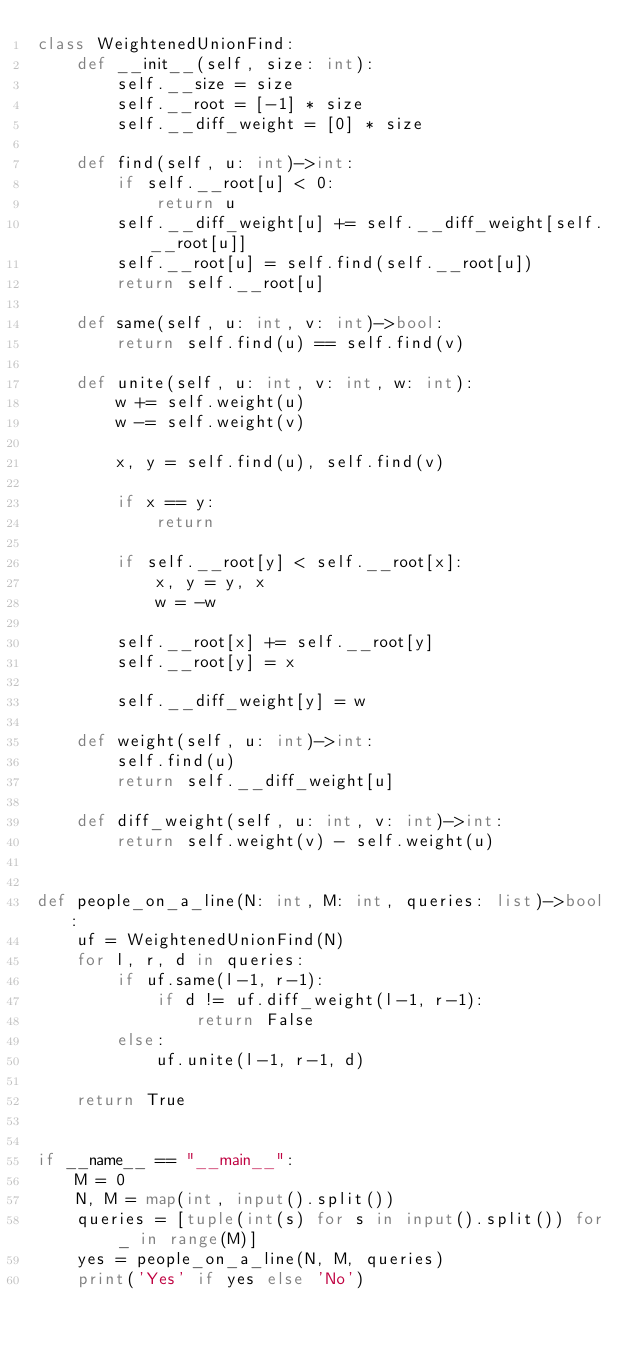<code> <loc_0><loc_0><loc_500><loc_500><_Python_>class WeightenedUnionFind:
    def __init__(self, size: int):
        self.__size = size
        self.__root = [-1] * size
        self.__diff_weight = [0] * size

    def find(self, u: int)->int:
        if self.__root[u] < 0:
            return u
        self.__diff_weight[u] += self.__diff_weight[self.__root[u]]
        self.__root[u] = self.find(self.__root[u])
        return self.__root[u]

    def same(self, u: int, v: int)->bool:
        return self.find(u) == self.find(v)

    def unite(self, u: int, v: int, w: int):
        w += self.weight(u)
        w -= self.weight(v)

        x, y = self.find(u), self.find(v)

        if x == y:
            return

        if self.__root[y] < self.__root[x]:
            x, y = y, x
            w = -w

        self.__root[x] += self.__root[y]
        self.__root[y] = x

        self.__diff_weight[y] = w

    def weight(self, u: int)->int:
        self.find(u)
        return self.__diff_weight[u]

    def diff_weight(self, u: int, v: int)->int:
        return self.weight(v) - self.weight(u)


def people_on_a_line(N: int, M: int, queries: list)->bool:
    uf = WeightenedUnionFind(N)
    for l, r, d in queries:
        if uf.same(l-1, r-1):
            if d != uf.diff_weight(l-1, r-1):
                return False
        else:
            uf.unite(l-1, r-1, d)

    return True


if __name__ == "__main__":
    M = 0
    N, M = map(int, input().split())
    queries = [tuple(int(s) for s in input().split()) for _ in range(M)]
    yes = people_on_a_line(N, M, queries)
    print('Yes' if yes else 'No')
</code> 